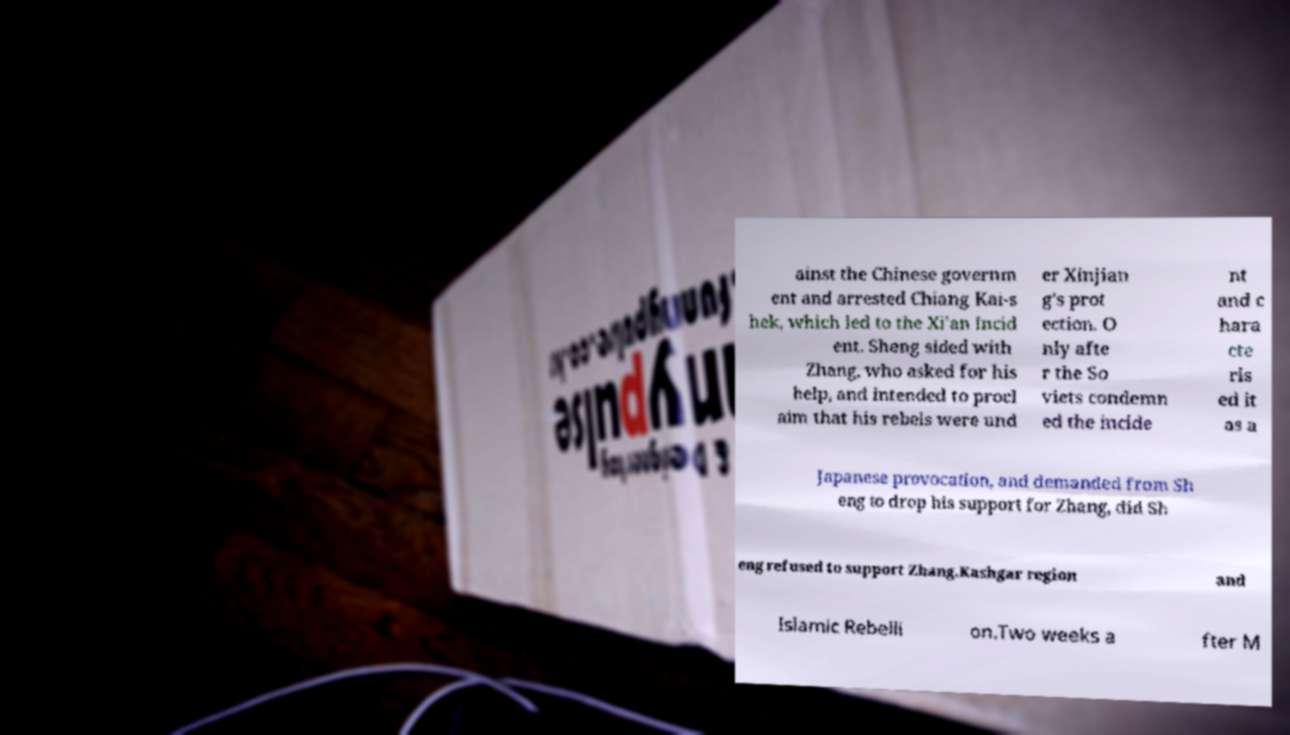What messages or text are displayed in this image? I need them in a readable, typed format. ainst the Chinese governm ent and arrested Chiang Kai-s hek, which led to the Xi'an Incid ent. Sheng sided with Zhang, who asked for his help, and intended to procl aim that his rebels were und er Xinjian g's prot ection. O nly afte r the So viets condemn ed the incide nt and c hara cte ris ed it as a Japanese provocation, and demanded from Sh eng to drop his support for Zhang, did Sh eng refused to support Zhang.Kashgar region and Islamic Rebelli on.Two weeks a fter M 